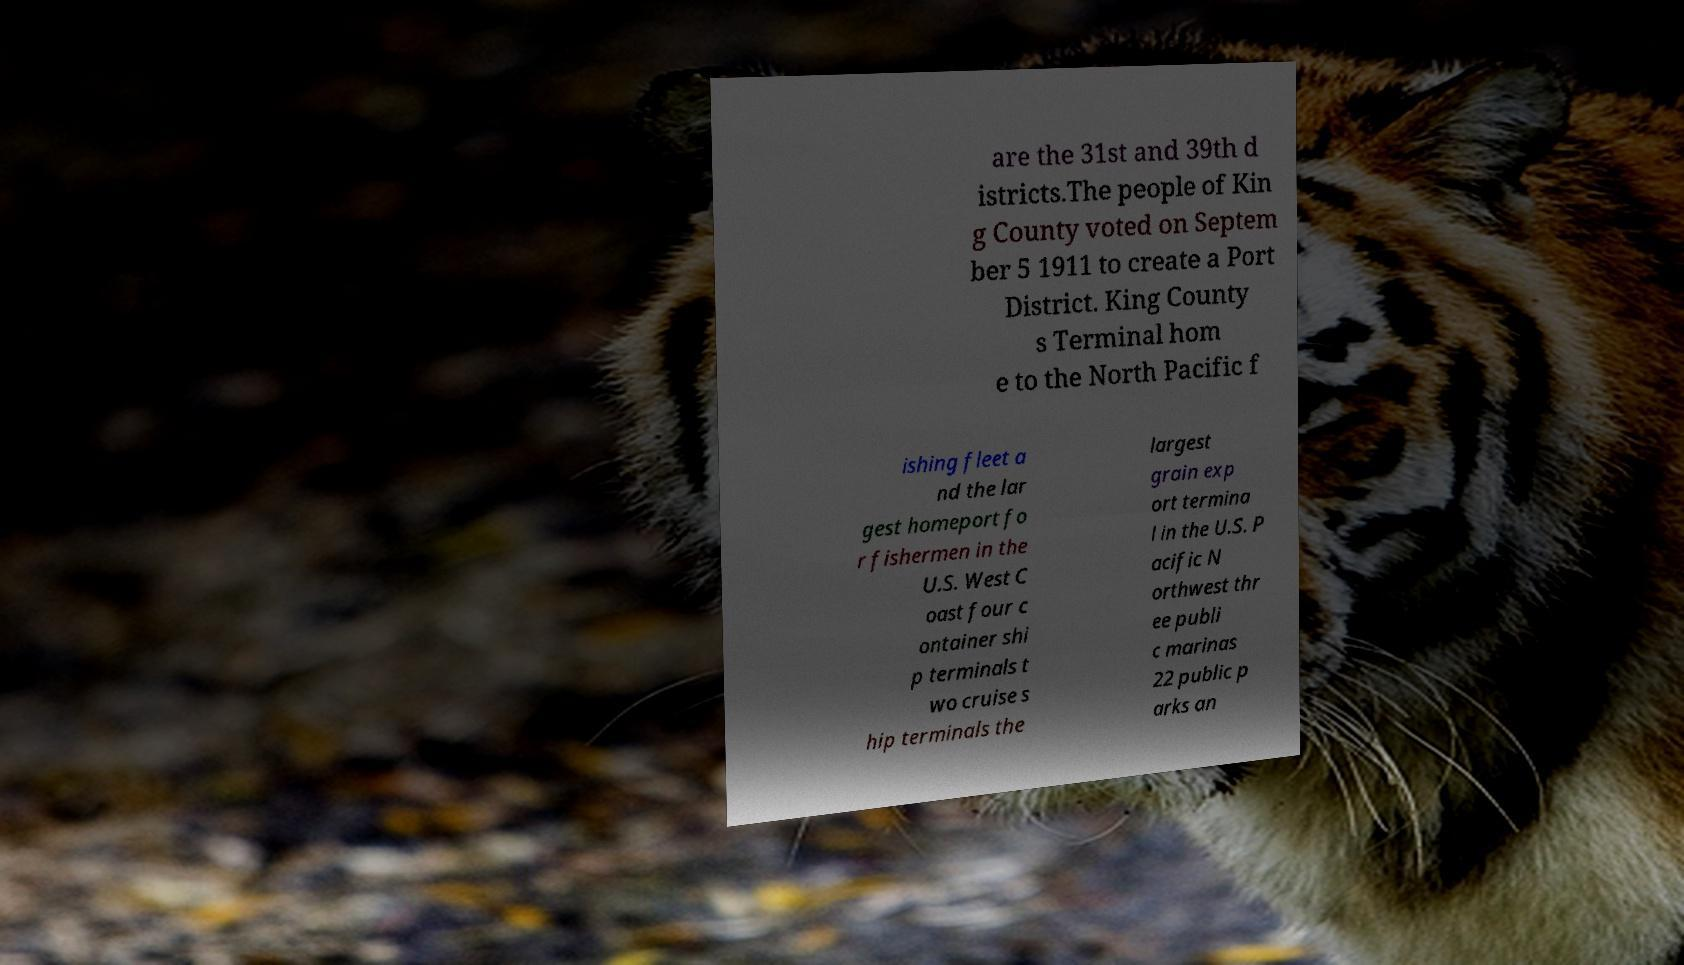Please identify and transcribe the text found in this image. are the 31st and 39th d istricts.The people of Kin g County voted on Septem ber 5 1911 to create a Port District. King County s Terminal hom e to the North Pacific f ishing fleet a nd the lar gest homeport fo r fishermen in the U.S. West C oast four c ontainer shi p terminals t wo cruise s hip terminals the largest grain exp ort termina l in the U.S. P acific N orthwest thr ee publi c marinas 22 public p arks an 